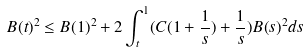Convert formula to latex. <formula><loc_0><loc_0><loc_500><loc_500>B ( t ) ^ { 2 } \leq B ( 1 ) ^ { 2 } + 2 \int _ { t } ^ { 1 } ( C ( 1 + \frac { 1 } { s } ) + \frac { 1 } { s } ) B ( s ) ^ { 2 } d s</formula> 